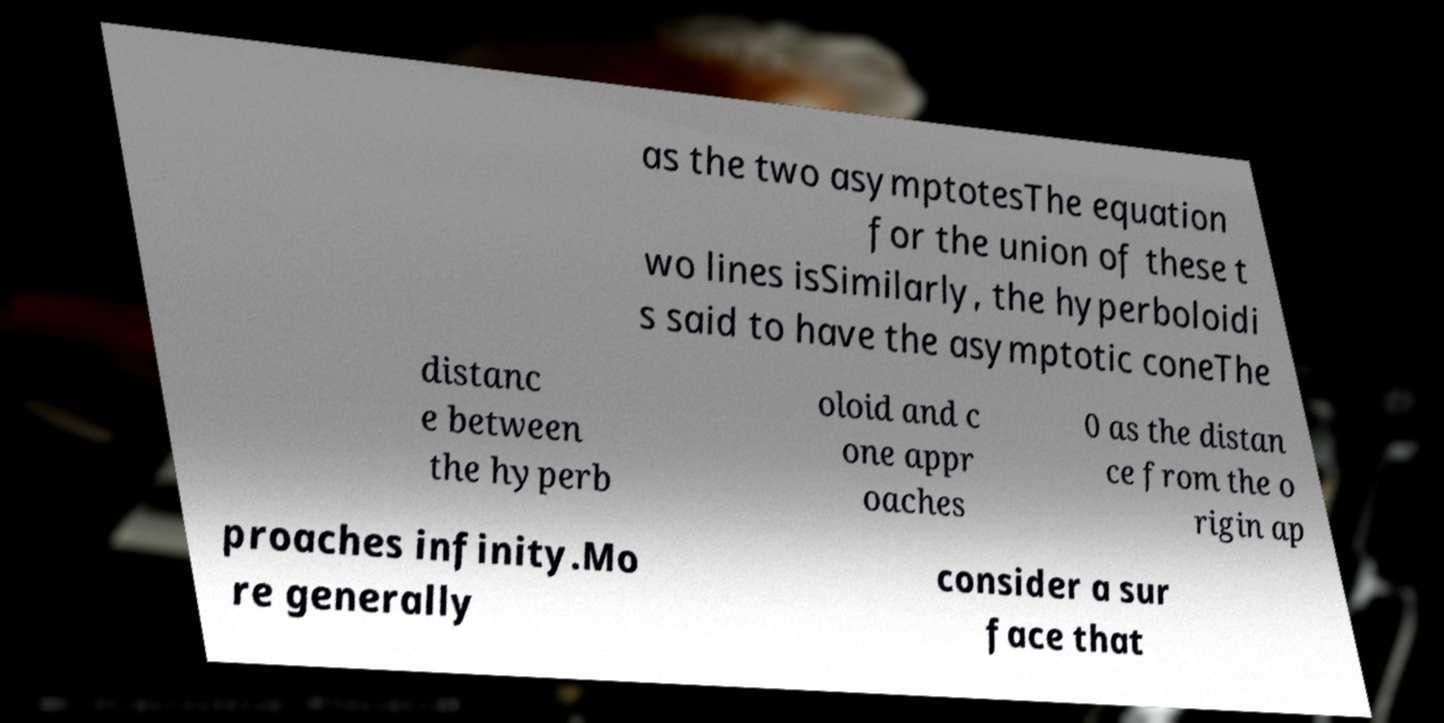Can you accurately transcribe the text from the provided image for me? as the two asymptotesThe equation for the union of these t wo lines isSimilarly, the hyperboloidi s said to have the asymptotic coneThe distanc e between the hyperb oloid and c one appr oaches 0 as the distan ce from the o rigin ap proaches infinity.Mo re generally consider a sur face that 